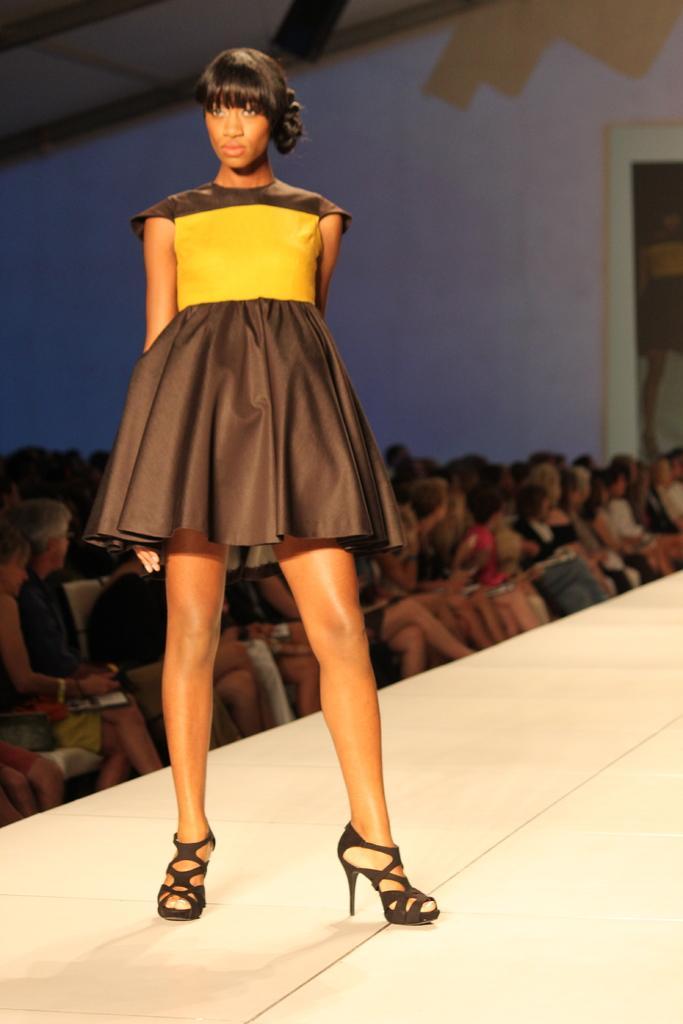In one or two sentences, can you explain what this image depicts? This image consists of a girl standing on the ramp. In the background, there are many people sitting. And we can see a wall. 